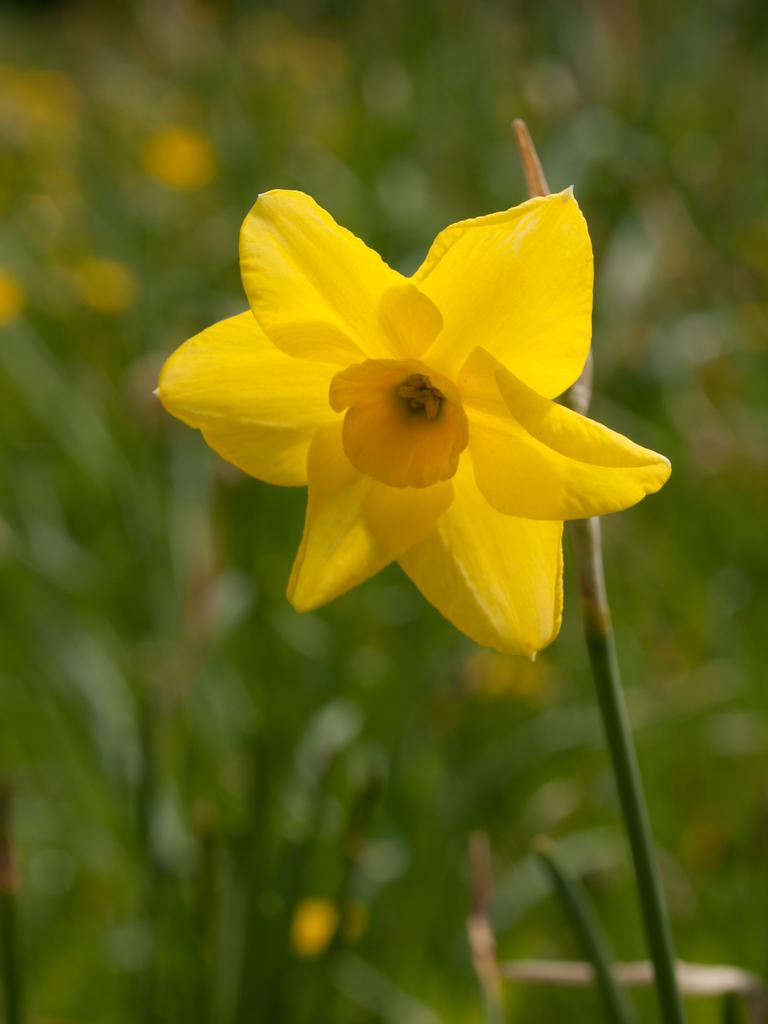What is the main subject in the front of the image? There is a flower in the front of the image. Can you describe the background of the image? The background of the image is blurry. What type of theory is being discussed in the cave in the image? There is no cave or discussion of a theory present in the image; it features a flower in the front and a blurry background. What is the head doing in the image? There is no head present in the image. 